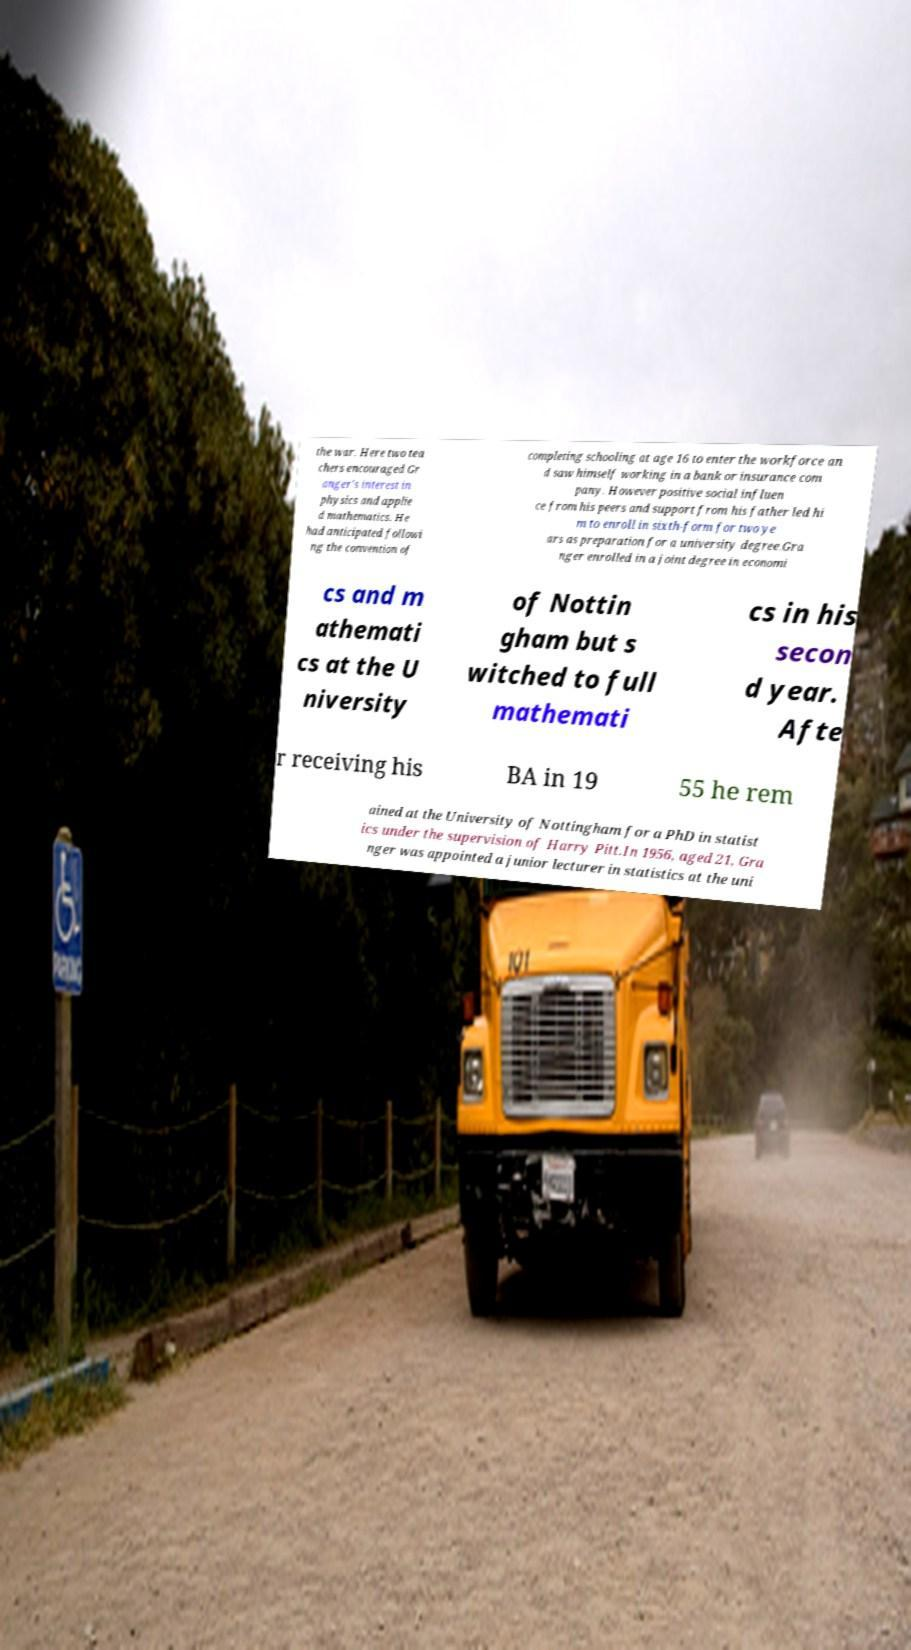Can you accurately transcribe the text from the provided image for me? the war. Here two tea chers encouraged Gr anger's interest in physics and applie d mathematics. He had anticipated followi ng the convention of completing schooling at age 16 to enter the workforce an d saw himself working in a bank or insurance com pany. However positive social influen ce from his peers and support from his father led hi m to enroll in sixth-form for two ye ars as preparation for a university degree.Gra nger enrolled in a joint degree in economi cs and m athemati cs at the U niversity of Nottin gham but s witched to full mathemati cs in his secon d year. Afte r receiving his BA in 19 55 he rem ained at the University of Nottingham for a PhD in statist ics under the supervision of Harry Pitt.In 1956, aged 21, Gra nger was appointed a junior lecturer in statistics at the uni 